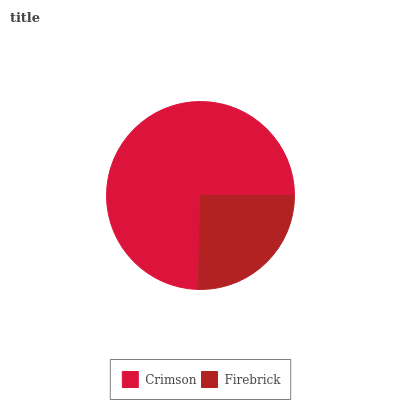Is Firebrick the minimum?
Answer yes or no. Yes. Is Crimson the maximum?
Answer yes or no. Yes. Is Firebrick the maximum?
Answer yes or no. No. Is Crimson greater than Firebrick?
Answer yes or no. Yes. Is Firebrick less than Crimson?
Answer yes or no. Yes. Is Firebrick greater than Crimson?
Answer yes or no. No. Is Crimson less than Firebrick?
Answer yes or no. No. Is Crimson the high median?
Answer yes or no. Yes. Is Firebrick the low median?
Answer yes or no. Yes. Is Firebrick the high median?
Answer yes or no. No. Is Crimson the low median?
Answer yes or no. No. 